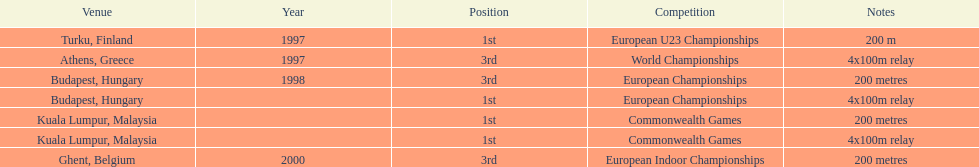List the competitions that have the same relay as world championships from athens, greece. European Championships, Commonwealth Games. 